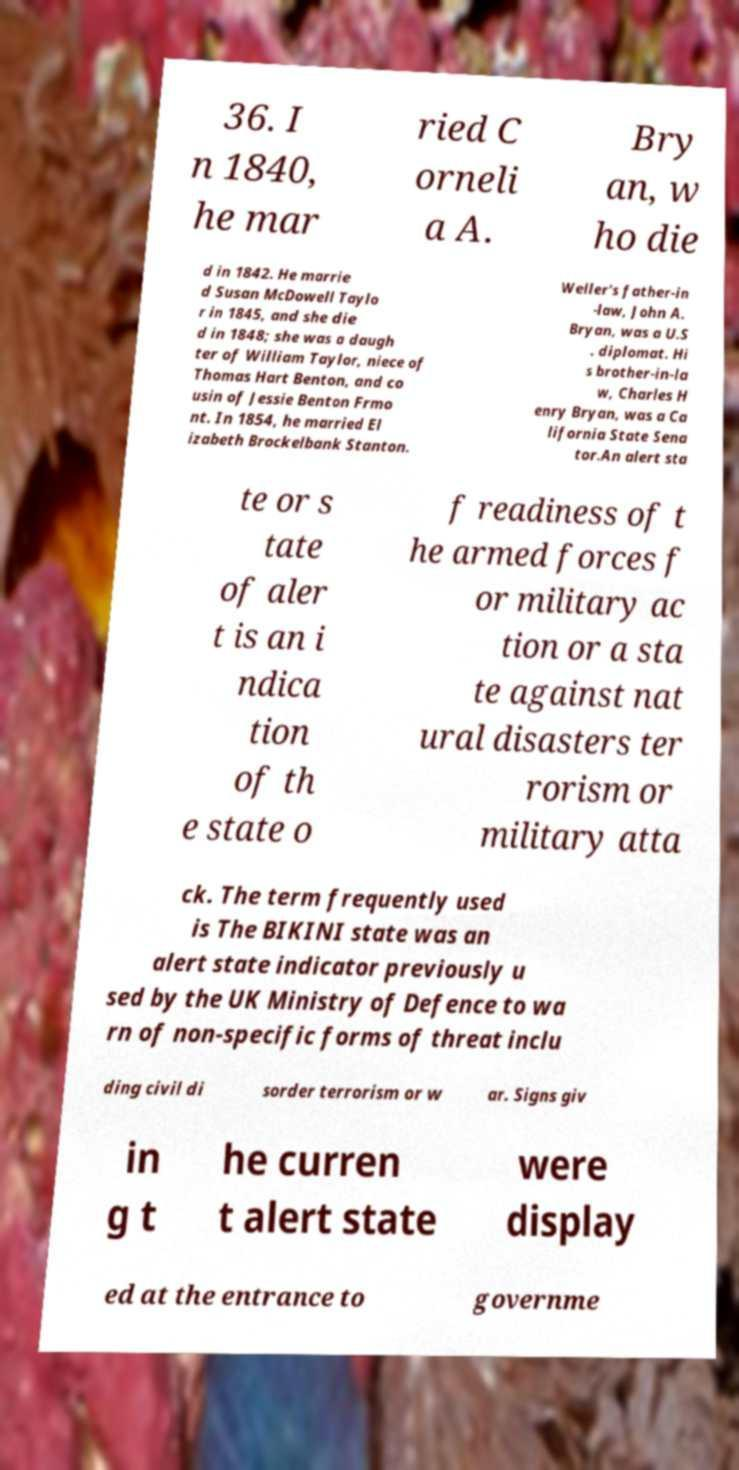Can you read and provide the text displayed in the image?This photo seems to have some interesting text. Can you extract and type it out for me? 36. I n 1840, he mar ried C orneli a A. Bry an, w ho die d in 1842. He marrie d Susan McDowell Taylo r in 1845, and she die d in 1848; she was a daugh ter of William Taylor, niece of Thomas Hart Benton, and co usin of Jessie Benton Frmo nt. In 1854, he married El izabeth Brockelbank Stanton. Weller's father-in -law, John A. Bryan, was a U.S . diplomat. Hi s brother-in-la w, Charles H enry Bryan, was a Ca lifornia State Sena tor.An alert sta te or s tate of aler t is an i ndica tion of th e state o f readiness of t he armed forces f or military ac tion or a sta te against nat ural disasters ter rorism or military atta ck. The term frequently used is The BIKINI state was an alert state indicator previously u sed by the UK Ministry of Defence to wa rn of non-specific forms of threat inclu ding civil di sorder terrorism or w ar. Signs giv in g t he curren t alert state were display ed at the entrance to governme 